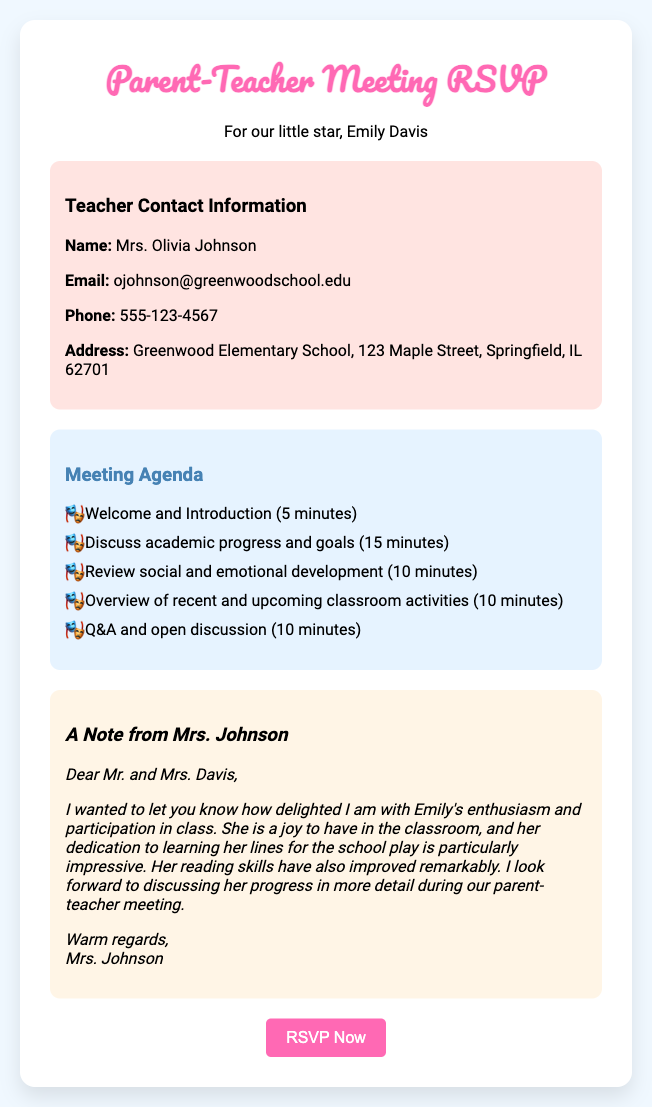What is the teacher's name? The teacher's name is provided in the contact information section of the document.
Answer: Mrs. Olivia Johnson What is the teacher's email address? The email address is listed in the contact information section under teacher details.
Answer: ojohnson@greenwoodschool.edu How many minutes are allocated for discussing academic progress? This information is detailed in the meeting agenda in the document.
Answer: 15 minutes What is the main topic for the Q&A session? The topic is indicated in the meeting agenda section of the document.
Answer: Open discussion How does Mrs. Johnson describe Emily's participation in class? This insight is found in the personalized note from Mrs. Johnson regarding Emily's progress.
Answer: A joy to have What is the address of Greenwood Elementary School? The address is included in the teacher contact information section of the document.
Answer: 123 Maple Street, Springfield, IL 62701 How many total items are listed in the meeting agenda? Count the items listed in the agenda section of the document to determine this.
Answer: 5 items What is the purpose of this document? The specific purpose can be inferred from the title and context provided.
Answer: RSVP for a Parent-Teacher Meeting What type of meeting does this RSVP card pertain to? The document title explicitly states the nature of the meeting.
Answer: Parent-Teacher Meeting 